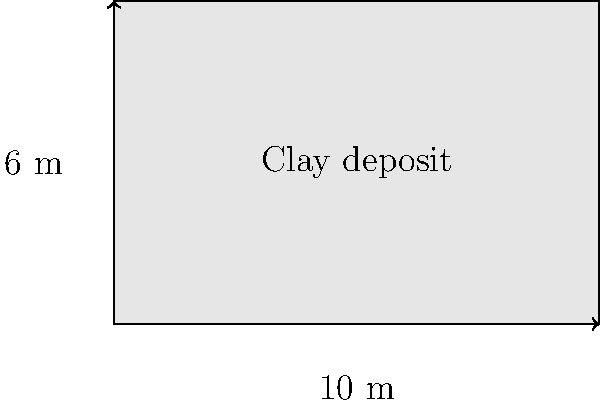As a botanist studying clay deposits in the jungle, you've discovered a unique clay formation. The cross-section of the deposit is rectangular, measuring 6 meters wide and 4 meters high. If the deposit extends 10 meters into the jungle, what is the total volume of clay in cubic meters? To calculate the volume of the clay deposit, we need to follow these steps:

1. Identify the shape: The clay deposit forms a rectangular prism.

2. Recall the formula for the volume of a rectangular prism:
   $$ V = l \times w \times h $$
   where $V$ is volume, $l$ is length, $w$ is width, and $h$ is height.

3. Identify the dimensions:
   - Length (depth into the jungle): $l = 10$ m
   - Width: $w = 6$ m
   - Height: $h = 4$ m

4. Substitute the values into the formula:
   $$ V = 10 \text{ m} \times 6 \text{ m} \times 4 \text{ m} $$

5. Perform the calculation:
   $$ V = 240 \text{ m}^3 $$

Therefore, the total volume of the clay deposit is 240 cubic meters.
Answer: $240 \text{ m}^3$ 